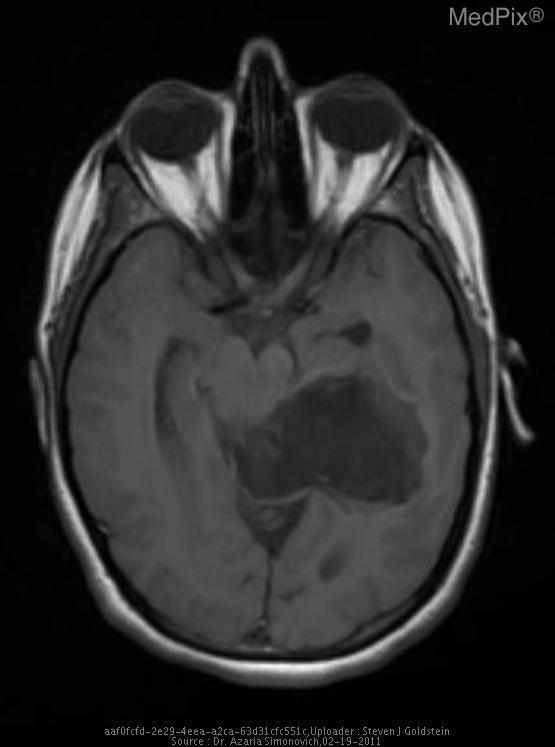Is there contrast in the vasculature?
Be succinct. No. Is/are the mass located near/in the mid brain?
Write a very short answer. Yes. Is the mass compressing the mid brain on this section?
Give a very brief answer. Yes. Is the mass pushing on the midbrain structures?
Quick response, please. Yes. Have brain structures crossed the midline of the brain?
Keep it brief. Yes. Is there evidence of midlight shift of structures on this mri?
Keep it brief. Yes. Do the left and right middle cerebral arteries appear patent on this section?
Be succinct. Yes. Is the left and right mca present?
Keep it brief. Yes. 